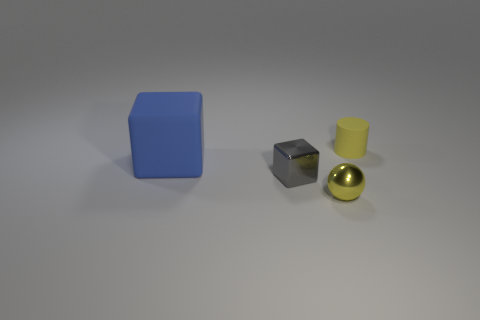Add 1 tiny red rubber cylinders. How many objects exist? 5 Subtract 1 balls. How many balls are left? 0 Subtract all blue cylinders. Subtract all purple spheres. How many cylinders are left? 1 Subtract all green cubes. How many purple cylinders are left? 0 Subtract all shiny things. Subtract all small gray things. How many objects are left? 1 Add 1 small things. How many small things are left? 4 Add 2 blocks. How many blocks exist? 4 Subtract 0 red spheres. How many objects are left? 4 Subtract all cylinders. How many objects are left? 3 